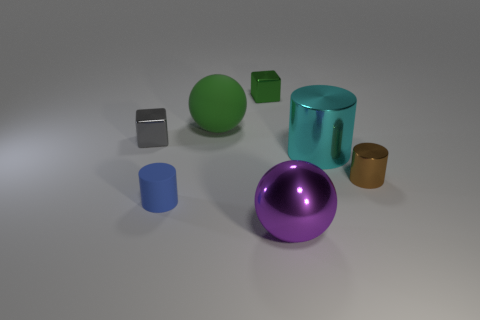Does the cyan metal cylinder have the same size as the green ball?
Offer a terse response. Yes. How many tiny blocks are right of the tiny brown object?
Offer a terse response. 0. Is the number of cyan objects that are in front of the gray metal object the same as the number of small blue objects to the right of the blue rubber thing?
Ensure brevity in your answer.  No. There is a big object that is on the right side of the big purple metal object; does it have the same shape as the small brown metallic thing?
Offer a very short reply. Yes. Is there any other thing that is the same material as the big purple ball?
Provide a succinct answer. Yes. There is a brown metal cylinder; does it have the same size as the metal cube on the left side of the green metallic object?
Offer a very short reply. Yes. What number of other things are the same color as the big metal ball?
Your answer should be very brief. 0. There is a gray object; are there any large green things left of it?
Offer a very short reply. No. What number of objects are large rubber balls or small cubes behind the green ball?
Make the answer very short. 2. There is a tiny metallic cube that is on the right side of the blue cylinder; are there any small brown shiny things behind it?
Give a very brief answer. No. 